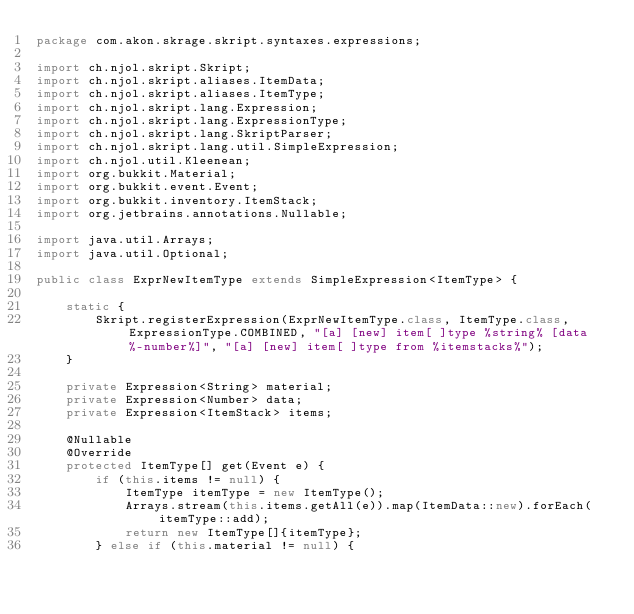Convert code to text. <code><loc_0><loc_0><loc_500><loc_500><_Java_>package com.akon.skrage.skript.syntaxes.expressions;

import ch.njol.skript.Skript;
import ch.njol.skript.aliases.ItemData;
import ch.njol.skript.aliases.ItemType;
import ch.njol.skript.lang.Expression;
import ch.njol.skript.lang.ExpressionType;
import ch.njol.skript.lang.SkriptParser;
import ch.njol.skript.lang.util.SimpleExpression;
import ch.njol.util.Kleenean;
import org.bukkit.Material;
import org.bukkit.event.Event;
import org.bukkit.inventory.ItemStack;
import org.jetbrains.annotations.Nullable;

import java.util.Arrays;
import java.util.Optional;

public class ExprNewItemType extends SimpleExpression<ItemType> {

    static {
        Skript.registerExpression(ExprNewItemType.class, ItemType.class, ExpressionType.COMBINED, "[a] [new] item[ ]type %string% [data %-number%]", "[a] [new] item[ ]type from %itemstacks%");
    }

    private Expression<String> material;
    private Expression<Number> data;
    private Expression<ItemStack> items;

    @Nullable
    @Override
    protected ItemType[] get(Event e) {
        if (this.items != null) {
            ItemType itemType = new ItemType();
            Arrays.stream(this.items.getAll(e)).map(ItemData::new).forEach(itemType::add);
            return new ItemType[]{itemType};
        } else if (this.material != null) {</code> 